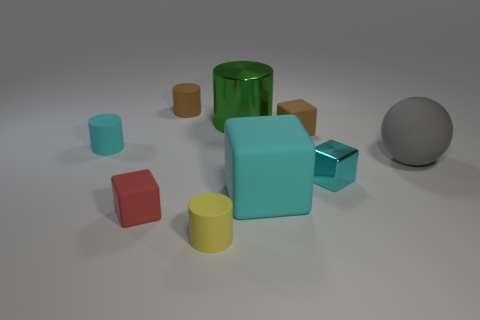Subtract all metallic blocks. How many blocks are left? 3 Add 1 tiny brown metallic spheres. How many objects exist? 10 Subtract all yellow cylinders. How many cylinders are left? 3 Subtract 3 cubes. How many cubes are left? 1 Subtract all green cylinders. How many cyan cubes are left? 2 Subtract all cubes. How many objects are left? 5 Add 8 green objects. How many green objects are left? 9 Add 7 big green things. How many big green things exist? 8 Subtract 0 yellow cubes. How many objects are left? 9 Subtract all brown cubes. Subtract all blue cylinders. How many cubes are left? 3 